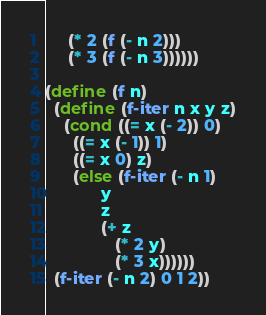Convert code to text. <code><loc_0><loc_0><loc_500><loc_500><_Scheme_>	 (* 2 (f (- n 2)))
	 (* 3 (f (- n 3))))))

(define (f n)
  (define (f-iter n x y z)
    (cond ((= x (- 2)) 0)
	  ((= x (- 1)) 1)
	  ((= x 0) z)
	  (else (f-iter (- n 1)
			y
			z
			(+ z
			   (* 2 y)
			   (* 3 x))))))
  (f-iter (- n 2) 0 1 2))</code> 